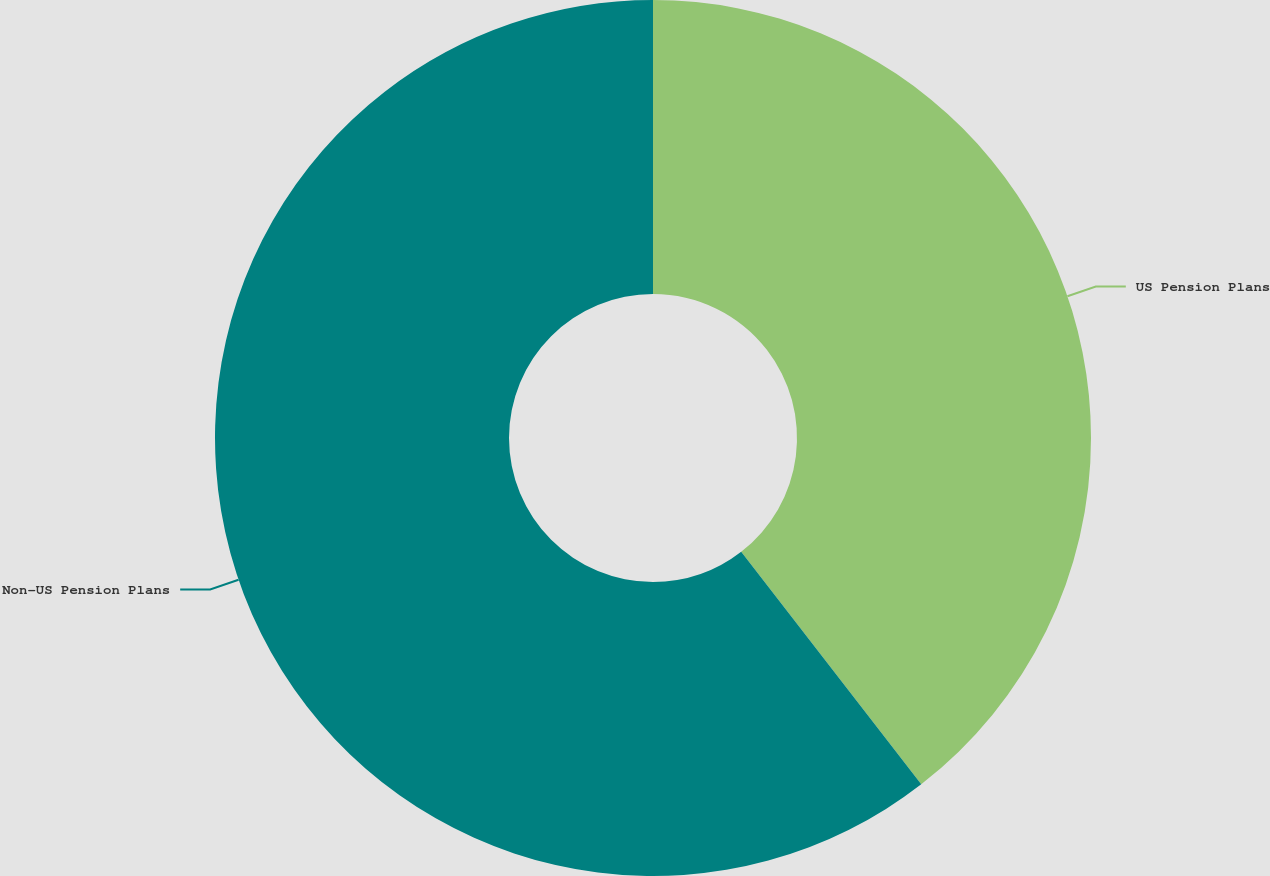<chart> <loc_0><loc_0><loc_500><loc_500><pie_chart><fcel>US Pension Plans<fcel>Non-US Pension Plans<nl><fcel>39.51%<fcel>60.49%<nl></chart> 